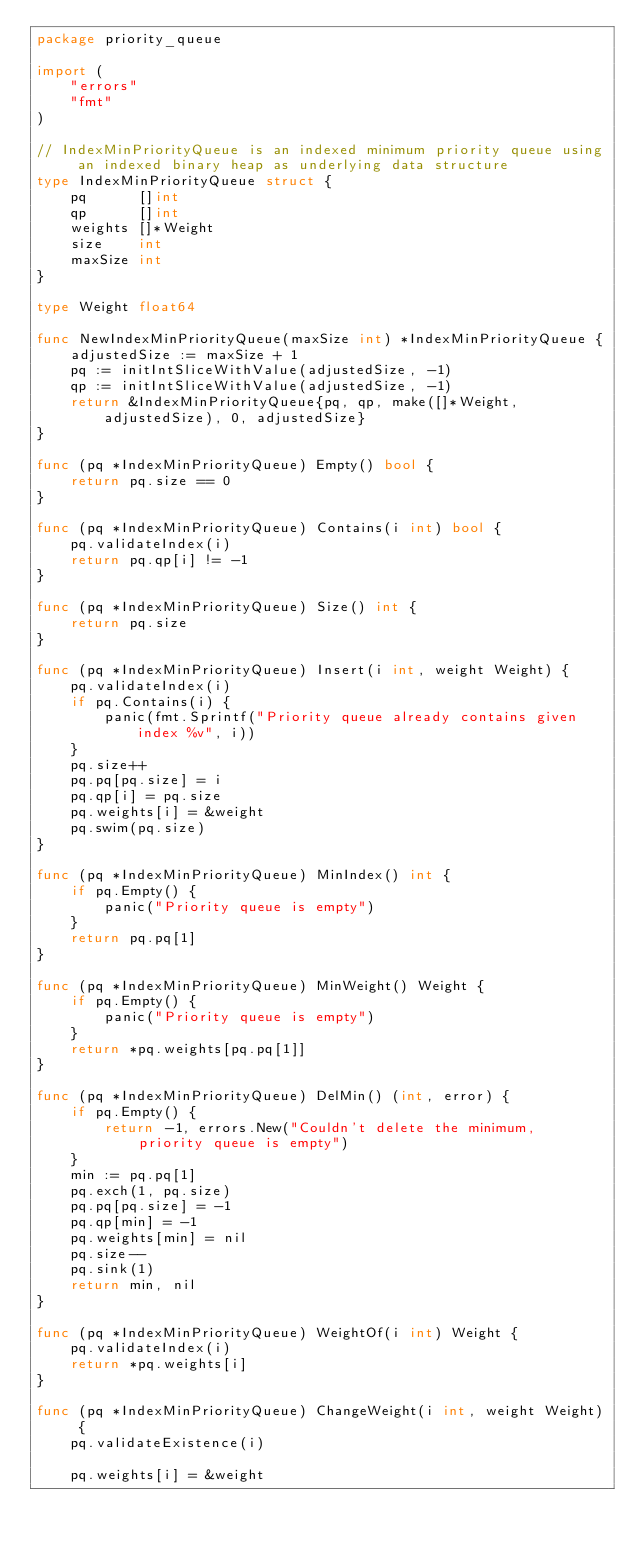Convert code to text. <code><loc_0><loc_0><loc_500><loc_500><_Go_>package priority_queue

import (
	"errors"
	"fmt"
)

// IndexMinPriorityQueue is an indexed minimum priority queue using an indexed binary heap as underlying data structure
type IndexMinPriorityQueue struct {
	pq      []int
	qp      []int
	weights []*Weight
	size    int
	maxSize int
}

type Weight float64

func NewIndexMinPriorityQueue(maxSize int) *IndexMinPriorityQueue {
	adjustedSize := maxSize + 1
	pq := initIntSliceWithValue(adjustedSize, -1)
	qp := initIntSliceWithValue(adjustedSize, -1)
	return &IndexMinPriorityQueue{pq, qp, make([]*Weight, adjustedSize), 0, adjustedSize}
}

func (pq *IndexMinPriorityQueue) Empty() bool {
	return pq.size == 0
}

func (pq *IndexMinPriorityQueue) Contains(i int) bool {
	pq.validateIndex(i)
	return pq.qp[i] != -1
}

func (pq *IndexMinPriorityQueue) Size() int {
	return pq.size
}

func (pq *IndexMinPriorityQueue) Insert(i int, weight Weight) {
	pq.validateIndex(i)
	if pq.Contains(i) {
		panic(fmt.Sprintf("Priority queue already contains given index %v", i))
	}
	pq.size++
	pq.pq[pq.size] = i
	pq.qp[i] = pq.size
	pq.weights[i] = &weight
	pq.swim(pq.size)
}

func (pq *IndexMinPriorityQueue) MinIndex() int {
	if pq.Empty() {
		panic("Priority queue is empty")
	}
	return pq.pq[1]
}

func (pq *IndexMinPriorityQueue) MinWeight() Weight {
	if pq.Empty() {
		panic("Priority queue is empty")
	}
	return *pq.weights[pq.pq[1]]
}

func (pq *IndexMinPriorityQueue) DelMin() (int, error) {
	if pq.Empty() {
		return -1, errors.New("Couldn't delete the minimum, priority queue is empty")
	}
	min := pq.pq[1]
	pq.exch(1, pq.size)
	pq.pq[pq.size] = -1
	pq.qp[min] = -1
	pq.weights[min] = nil
	pq.size--
	pq.sink(1)
	return min, nil
}

func (pq *IndexMinPriorityQueue) WeightOf(i int) Weight {
	pq.validateIndex(i)
	return *pq.weights[i]
}

func (pq *IndexMinPriorityQueue) ChangeWeight(i int, weight Weight) {
	pq.validateExistence(i)

	pq.weights[i] = &weight</code> 